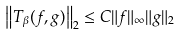Convert formula to latex. <formula><loc_0><loc_0><loc_500><loc_500>\left \| T _ { \beta } ( f , g ) \right \| _ { 2 } \leq C \| f \| _ { \infty } \| g \| _ { 2 } \,</formula> 